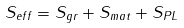<formula> <loc_0><loc_0><loc_500><loc_500>S _ { e f f } = S _ { g r } + S _ { m a t } + S _ { P L }</formula> 